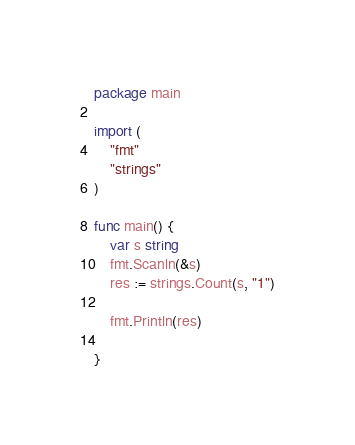Convert code to text. <code><loc_0><loc_0><loc_500><loc_500><_Go_>package main

import (
	"fmt"
	"strings"
)

func main() {
	var s string
	fmt.Scanln(&s)
	res := strings.Count(s, "1")

	fmt.Println(res)

}
</code> 